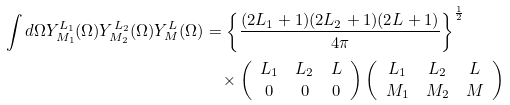<formula> <loc_0><loc_0><loc_500><loc_500>\int d \Omega Y _ { M _ { 1 } } ^ { L _ { 1 } } ( \Omega ) Y _ { M _ { 2 } } ^ { L _ { 2 } } ( \Omega ) Y _ { M } ^ { L } ( \Omega ) & = \left \{ \frac { ( 2 L _ { 1 } + 1 ) ( 2 L _ { 2 } + 1 ) ( 2 L + 1 ) } { 4 \pi } \right \} ^ { \frac { 1 } { 2 } } \\ & \quad \times \left ( \begin{array} { c c c } L _ { 1 } & L _ { 2 } & L \\ 0 & 0 & 0 \end{array} \right ) \left ( \begin{array} { c c c } L _ { 1 } & L _ { 2 } & L \\ M _ { 1 } & M _ { 2 } & M \end{array} \right )</formula> 